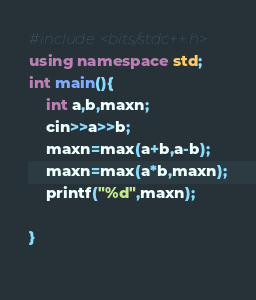Convert code to text. <code><loc_0><loc_0><loc_500><loc_500><_C++_>#include<bits/stdc++.h>
using namespace std;
int main(){
	int a,b,maxn;
	cin>>a>>b;
	maxn=max(a+b,a-b);
	maxn=max(a*b,maxn);
	printf("%d",maxn);
	
}
 </code> 